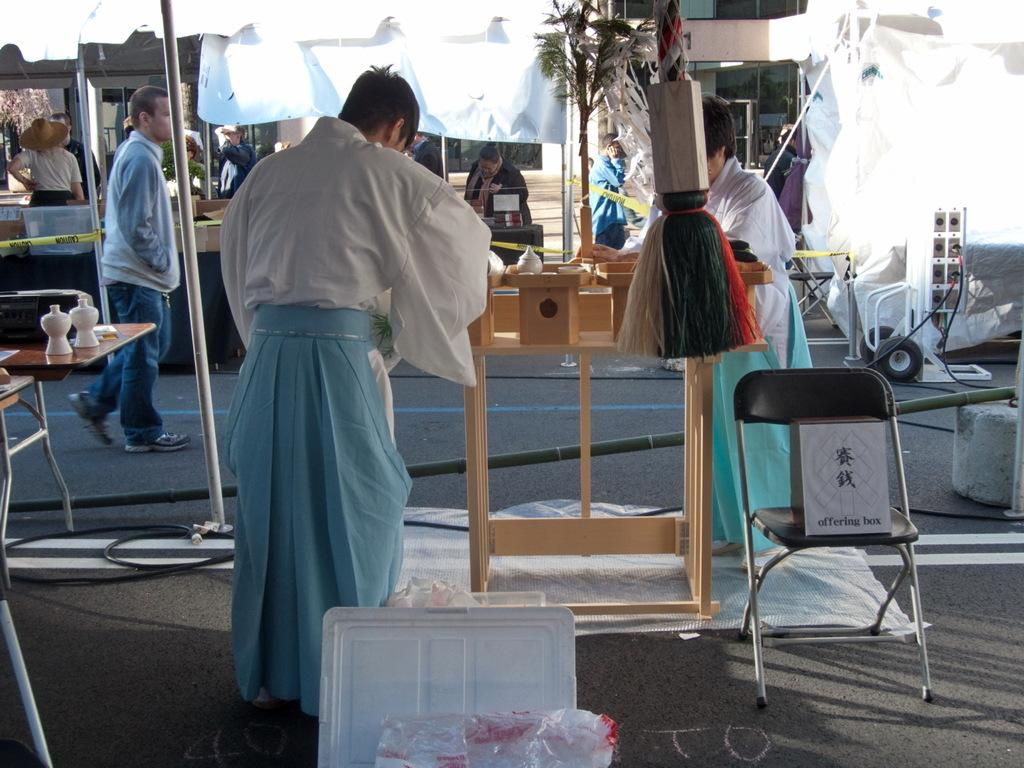What are the people in the image doing? The people in the image are standing on the road. What furniture items can be seen in the image? There is a chair and a table in the image. What other objects are present in the image? There is a pole and a plant in the image. What type of cap is the plant wearing in the image? There is no cap present on the plant in the image. 